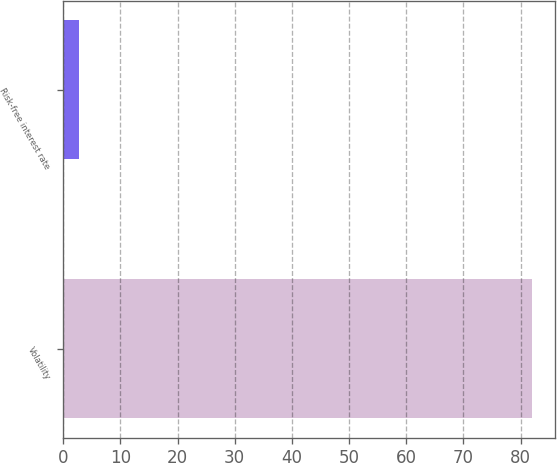Convert chart to OTSL. <chart><loc_0><loc_0><loc_500><loc_500><bar_chart><fcel>Volatility<fcel>Risk-free interest rate<nl><fcel>82<fcel>2.81<nl></chart> 